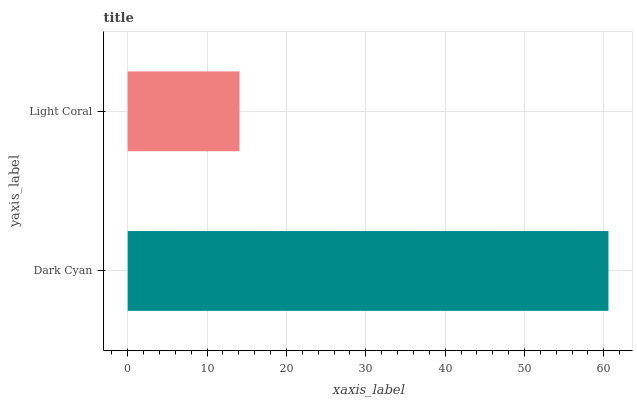Is Light Coral the minimum?
Answer yes or no. Yes. Is Dark Cyan the maximum?
Answer yes or no. Yes. Is Light Coral the maximum?
Answer yes or no. No. Is Dark Cyan greater than Light Coral?
Answer yes or no. Yes. Is Light Coral less than Dark Cyan?
Answer yes or no. Yes. Is Light Coral greater than Dark Cyan?
Answer yes or no. No. Is Dark Cyan less than Light Coral?
Answer yes or no. No. Is Dark Cyan the high median?
Answer yes or no. Yes. Is Light Coral the low median?
Answer yes or no. Yes. Is Light Coral the high median?
Answer yes or no. No. Is Dark Cyan the low median?
Answer yes or no. No. 